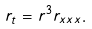<formula> <loc_0><loc_0><loc_500><loc_500>r _ { t } = r ^ { 3 } r _ { x x x } .</formula> 